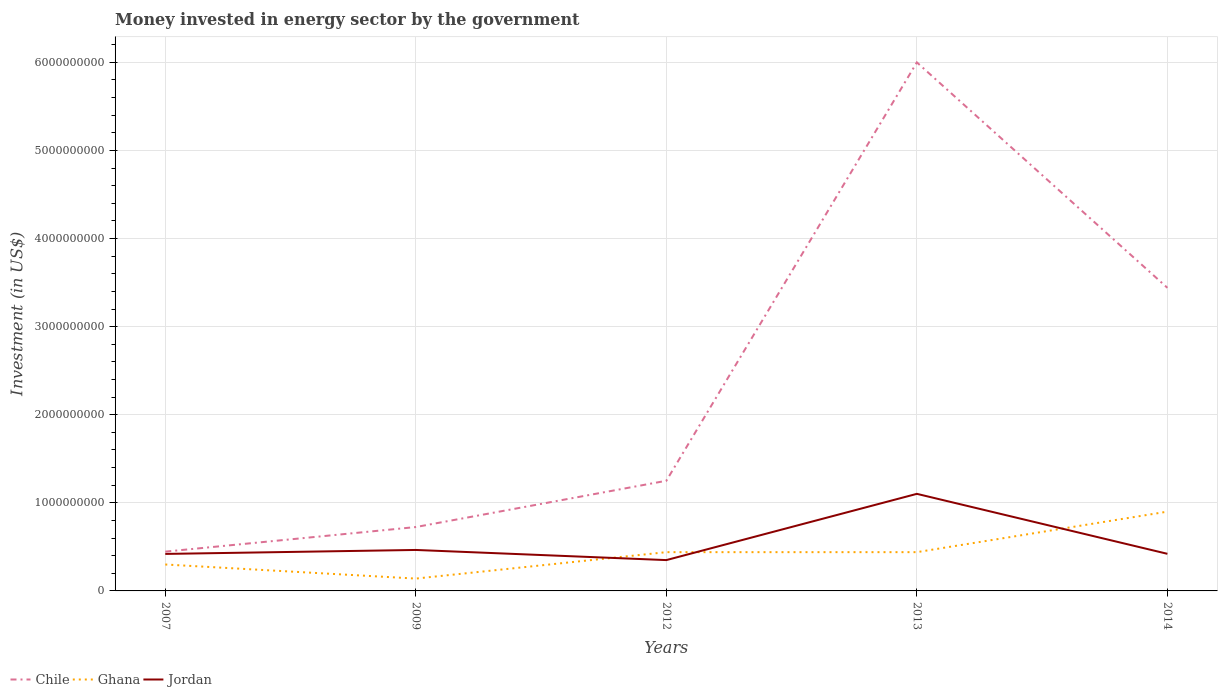Is the number of lines equal to the number of legend labels?
Ensure brevity in your answer.  Yes. Across all years, what is the maximum money spent in energy sector in Jordan?
Offer a very short reply. 3.50e+08. In which year was the money spent in energy sector in Jordan maximum?
Offer a terse response. 2012. What is the total money spent in energy sector in Ghana in the graph?
Provide a succinct answer. 1.60e+08. What is the difference between the highest and the second highest money spent in energy sector in Jordan?
Offer a terse response. 7.52e+08. How many years are there in the graph?
Provide a succinct answer. 5. What is the difference between two consecutive major ticks on the Y-axis?
Offer a terse response. 1.00e+09. Where does the legend appear in the graph?
Offer a terse response. Bottom left. How many legend labels are there?
Give a very brief answer. 3. How are the legend labels stacked?
Your response must be concise. Horizontal. What is the title of the graph?
Offer a very short reply. Money invested in energy sector by the government. What is the label or title of the Y-axis?
Give a very brief answer. Investment (in US$). What is the Investment (in US$) of Chile in 2007?
Make the answer very short. 4.46e+08. What is the Investment (in US$) of Ghana in 2007?
Offer a terse response. 3.00e+08. What is the Investment (in US$) of Jordan in 2007?
Your answer should be compact. 4.20e+08. What is the Investment (in US$) of Chile in 2009?
Keep it short and to the point. 7.25e+08. What is the Investment (in US$) in Ghana in 2009?
Give a very brief answer. 1.40e+08. What is the Investment (in US$) in Jordan in 2009?
Give a very brief answer. 4.65e+08. What is the Investment (in US$) in Chile in 2012?
Your response must be concise. 1.25e+09. What is the Investment (in US$) in Ghana in 2012?
Your answer should be very brief. 4.40e+08. What is the Investment (in US$) in Jordan in 2012?
Offer a very short reply. 3.50e+08. What is the Investment (in US$) of Chile in 2013?
Offer a terse response. 6.00e+09. What is the Investment (in US$) in Ghana in 2013?
Offer a very short reply. 4.40e+08. What is the Investment (in US$) of Jordan in 2013?
Keep it short and to the point. 1.10e+09. What is the Investment (in US$) in Chile in 2014?
Give a very brief answer. 3.44e+09. What is the Investment (in US$) in Ghana in 2014?
Offer a terse response. 9.00e+08. What is the Investment (in US$) in Jordan in 2014?
Keep it short and to the point. 4.21e+08. Across all years, what is the maximum Investment (in US$) in Chile?
Offer a terse response. 6.00e+09. Across all years, what is the maximum Investment (in US$) of Ghana?
Your answer should be compact. 9.00e+08. Across all years, what is the maximum Investment (in US$) of Jordan?
Give a very brief answer. 1.10e+09. Across all years, what is the minimum Investment (in US$) of Chile?
Your answer should be compact. 4.46e+08. Across all years, what is the minimum Investment (in US$) of Ghana?
Provide a succinct answer. 1.40e+08. Across all years, what is the minimum Investment (in US$) of Jordan?
Offer a very short reply. 3.50e+08. What is the total Investment (in US$) in Chile in the graph?
Provide a succinct answer. 1.19e+1. What is the total Investment (in US$) of Ghana in the graph?
Give a very brief answer. 2.22e+09. What is the total Investment (in US$) of Jordan in the graph?
Keep it short and to the point. 2.76e+09. What is the difference between the Investment (in US$) in Chile in 2007 and that in 2009?
Your response must be concise. -2.79e+08. What is the difference between the Investment (in US$) in Ghana in 2007 and that in 2009?
Provide a succinct answer. 1.60e+08. What is the difference between the Investment (in US$) in Jordan in 2007 and that in 2009?
Offer a very short reply. -4.50e+07. What is the difference between the Investment (in US$) in Chile in 2007 and that in 2012?
Your response must be concise. -8.05e+08. What is the difference between the Investment (in US$) of Ghana in 2007 and that in 2012?
Your response must be concise. -1.40e+08. What is the difference between the Investment (in US$) in Jordan in 2007 and that in 2012?
Your response must be concise. 7.00e+07. What is the difference between the Investment (in US$) of Chile in 2007 and that in 2013?
Offer a very short reply. -5.55e+09. What is the difference between the Investment (in US$) of Ghana in 2007 and that in 2013?
Provide a succinct answer. -1.40e+08. What is the difference between the Investment (in US$) in Jordan in 2007 and that in 2013?
Make the answer very short. -6.82e+08. What is the difference between the Investment (in US$) of Chile in 2007 and that in 2014?
Give a very brief answer. -2.99e+09. What is the difference between the Investment (in US$) of Ghana in 2007 and that in 2014?
Provide a short and direct response. -6.00e+08. What is the difference between the Investment (in US$) in Jordan in 2007 and that in 2014?
Give a very brief answer. -1.20e+06. What is the difference between the Investment (in US$) in Chile in 2009 and that in 2012?
Give a very brief answer. -5.25e+08. What is the difference between the Investment (in US$) in Ghana in 2009 and that in 2012?
Make the answer very short. -3.00e+08. What is the difference between the Investment (in US$) in Jordan in 2009 and that in 2012?
Give a very brief answer. 1.15e+08. What is the difference between the Investment (in US$) of Chile in 2009 and that in 2013?
Keep it short and to the point. -5.27e+09. What is the difference between the Investment (in US$) in Ghana in 2009 and that in 2013?
Offer a very short reply. -3.00e+08. What is the difference between the Investment (in US$) in Jordan in 2009 and that in 2013?
Your answer should be very brief. -6.37e+08. What is the difference between the Investment (in US$) in Chile in 2009 and that in 2014?
Your answer should be compact. -2.72e+09. What is the difference between the Investment (in US$) of Ghana in 2009 and that in 2014?
Ensure brevity in your answer.  -7.60e+08. What is the difference between the Investment (in US$) of Jordan in 2009 and that in 2014?
Give a very brief answer. 4.38e+07. What is the difference between the Investment (in US$) of Chile in 2012 and that in 2013?
Your response must be concise. -4.75e+09. What is the difference between the Investment (in US$) in Jordan in 2012 and that in 2013?
Your answer should be compact. -7.52e+08. What is the difference between the Investment (in US$) in Chile in 2012 and that in 2014?
Give a very brief answer. -2.19e+09. What is the difference between the Investment (in US$) of Ghana in 2012 and that in 2014?
Make the answer very short. -4.60e+08. What is the difference between the Investment (in US$) of Jordan in 2012 and that in 2014?
Ensure brevity in your answer.  -7.12e+07. What is the difference between the Investment (in US$) in Chile in 2013 and that in 2014?
Offer a very short reply. 2.56e+09. What is the difference between the Investment (in US$) of Ghana in 2013 and that in 2014?
Make the answer very short. -4.60e+08. What is the difference between the Investment (in US$) in Jordan in 2013 and that in 2014?
Provide a succinct answer. 6.81e+08. What is the difference between the Investment (in US$) in Chile in 2007 and the Investment (in US$) in Ghana in 2009?
Provide a short and direct response. 3.06e+08. What is the difference between the Investment (in US$) of Chile in 2007 and the Investment (in US$) of Jordan in 2009?
Ensure brevity in your answer.  -1.90e+07. What is the difference between the Investment (in US$) of Ghana in 2007 and the Investment (in US$) of Jordan in 2009?
Ensure brevity in your answer.  -1.65e+08. What is the difference between the Investment (in US$) in Chile in 2007 and the Investment (in US$) in Ghana in 2012?
Offer a terse response. 5.96e+06. What is the difference between the Investment (in US$) in Chile in 2007 and the Investment (in US$) in Jordan in 2012?
Your response must be concise. 9.60e+07. What is the difference between the Investment (in US$) in Ghana in 2007 and the Investment (in US$) in Jordan in 2012?
Your response must be concise. -5.00e+07. What is the difference between the Investment (in US$) in Chile in 2007 and the Investment (in US$) in Ghana in 2013?
Make the answer very short. 5.96e+06. What is the difference between the Investment (in US$) in Chile in 2007 and the Investment (in US$) in Jordan in 2013?
Ensure brevity in your answer.  -6.56e+08. What is the difference between the Investment (in US$) in Ghana in 2007 and the Investment (in US$) in Jordan in 2013?
Keep it short and to the point. -8.02e+08. What is the difference between the Investment (in US$) of Chile in 2007 and the Investment (in US$) of Ghana in 2014?
Ensure brevity in your answer.  -4.54e+08. What is the difference between the Investment (in US$) of Chile in 2007 and the Investment (in US$) of Jordan in 2014?
Provide a short and direct response. 2.48e+07. What is the difference between the Investment (in US$) in Ghana in 2007 and the Investment (in US$) in Jordan in 2014?
Give a very brief answer. -1.21e+08. What is the difference between the Investment (in US$) of Chile in 2009 and the Investment (in US$) of Ghana in 2012?
Your answer should be very brief. 2.85e+08. What is the difference between the Investment (in US$) in Chile in 2009 and the Investment (in US$) in Jordan in 2012?
Keep it short and to the point. 3.75e+08. What is the difference between the Investment (in US$) of Ghana in 2009 and the Investment (in US$) of Jordan in 2012?
Keep it short and to the point. -2.10e+08. What is the difference between the Investment (in US$) of Chile in 2009 and the Investment (in US$) of Ghana in 2013?
Make the answer very short. 2.85e+08. What is the difference between the Investment (in US$) in Chile in 2009 and the Investment (in US$) in Jordan in 2013?
Your answer should be very brief. -3.77e+08. What is the difference between the Investment (in US$) in Ghana in 2009 and the Investment (in US$) in Jordan in 2013?
Give a very brief answer. -9.62e+08. What is the difference between the Investment (in US$) in Chile in 2009 and the Investment (in US$) in Ghana in 2014?
Offer a very short reply. -1.75e+08. What is the difference between the Investment (in US$) of Chile in 2009 and the Investment (in US$) of Jordan in 2014?
Your response must be concise. 3.04e+08. What is the difference between the Investment (in US$) in Ghana in 2009 and the Investment (in US$) in Jordan in 2014?
Offer a very short reply. -2.81e+08. What is the difference between the Investment (in US$) in Chile in 2012 and the Investment (in US$) in Ghana in 2013?
Offer a terse response. 8.10e+08. What is the difference between the Investment (in US$) of Chile in 2012 and the Investment (in US$) of Jordan in 2013?
Make the answer very short. 1.48e+08. What is the difference between the Investment (in US$) of Ghana in 2012 and the Investment (in US$) of Jordan in 2013?
Offer a very short reply. -6.62e+08. What is the difference between the Investment (in US$) of Chile in 2012 and the Investment (in US$) of Ghana in 2014?
Provide a short and direct response. 3.50e+08. What is the difference between the Investment (in US$) of Chile in 2012 and the Investment (in US$) of Jordan in 2014?
Your answer should be compact. 8.29e+08. What is the difference between the Investment (in US$) of Ghana in 2012 and the Investment (in US$) of Jordan in 2014?
Ensure brevity in your answer.  1.88e+07. What is the difference between the Investment (in US$) of Chile in 2013 and the Investment (in US$) of Ghana in 2014?
Ensure brevity in your answer.  5.10e+09. What is the difference between the Investment (in US$) in Chile in 2013 and the Investment (in US$) in Jordan in 2014?
Your response must be concise. 5.58e+09. What is the difference between the Investment (in US$) in Ghana in 2013 and the Investment (in US$) in Jordan in 2014?
Make the answer very short. 1.88e+07. What is the average Investment (in US$) in Chile per year?
Your answer should be compact. 2.37e+09. What is the average Investment (in US$) of Ghana per year?
Offer a terse response. 4.44e+08. What is the average Investment (in US$) of Jordan per year?
Your answer should be very brief. 5.52e+08. In the year 2007, what is the difference between the Investment (in US$) in Chile and Investment (in US$) in Ghana?
Offer a very short reply. 1.46e+08. In the year 2007, what is the difference between the Investment (in US$) of Chile and Investment (in US$) of Jordan?
Offer a terse response. 2.60e+07. In the year 2007, what is the difference between the Investment (in US$) in Ghana and Investment (in US$) in Jordan?
Offer a terse response. -1.20e+08. In the year 2009, what is the difference between the Investment (in US$) in Chile and Investment (in US$) in Ghana?
Your answer should be compact. 5.85e+08. In the year 2009, what is the difference between the Investment (in US$) in Chile and Investment (in US$) in Jordan?
Your response must be concise. 2.60e+08. In the year 2009, what is the difference between the Investment (in US$) in Ghana and Investment (in US$) in Jordan?
Provide a succinct answer. -3.25e+08. In the year 2012, what is the difference between the Investment (in US$) of Chile and Investment (in US$) of Ghana?
Provide a short and direct response. 8.10e+08. In the year 2012, what is the difference between the Investment (in US$) of Chile and Investment (in US$) of Jordan?
Keep it short and to the point. 9.00e+08. In the year 2012, what is the difference between the Investment (in US$) of Ghana and Investment (in US$) of Jordan?
Keep it short and to the point. 9.00e+07. In the year 2013, what is the difference between the Investment (in US$) of Chile and Investment (in US$) of Ghana?
Your response must be concise. 5.56e+09. In the year 2013, what is the difference between the Investment (in US$) in Chile and Investment (in US$) in Jordan?
Provide a short and direct response. 4.90e+09. In the year 2013, what is the difference between the Investment (in US$) in Ghana and Investment (in US$) in Jordan?
Keep it short and to the point. -6.62e+08. In the year 2014, what is the difference between the Investment (in US$) in Chile and Investment (in US$) in Ghana?
Make the answer very short. 2.54e+09. In the year 2014, what is the difference between the Investment (in US$) of Chile and Investment (in US$) of Jordan?
Your answer should be compact. 3.02e+09. In the year 2014, what is the difference between the Investment (in US$) of Ghana and Investment (in US$) of Jordan?
Your answer should be very brief. 4.79e+08. What is the ratio of the Investment (in US$) of Chile in 2007 to that in 2009?
Make the answer very short. 0.61. What is the ratio of the Investment (in US$) of Ghana in 2007 to that in 2009?
Ensure brevity in your answer.  2.14. What is the ratio of the Investment (in US$) of Jordan in 2007 to that in 2009?
Offer a very short reply. 0.9. What is the ratio of the Investment (in US$) of Chile in 2007 to that in 2012?
Keep it short and to the point. 0.36. What is the ratio of the Investment (in US$) of Ghana in 2007 to that in 2012?
Make the answer very short. 0.68. What is the ratio of the Investment (in US$) in Jordan in 2007 to that in 2012?
Offer a very short reply. 1.2. What is the ratio of the Investment (in US$) in Chile in 2007 to that in 2013?
Provide a succinct answer. 0.07. What is the ratio of the Investment (in US$) of Ghana in 2007 to that in 2013?
Ensure brevity in your answer.  0.68. What is the ratio of the Investment (in US$) of Jordan in 2007 to that in 2013?
Give a very brief answer. 0.38. What is the ratio of the Investment (in US$) of Chile in 2007 to that in 2014?
Your response must be concise. 0.13. What is the ratio of the Investment (in US$) in Ghana in 2007 to that in 2014?
Provide a short and direct response. 0.33. What is the ratio of the Investment (in US$) in Jordan in 2007 to that in 2014?
Keep it short and to the point. 1. What is the ratio of the Investment (in US$) of Chile in 2009 to that in 2012?
Offer a terse response. 0.58. What is the ratio of the Investment (in US$) of Ghana in 2009 to that in 2012?
Keep it short and to the point. 0.32. What is the ratio of the Investment (in US$) in Jordan in 2009 to that in 2012?
Offer a terse response. 1.33. What is the ratio of the Investment (in US$) in Chile in 2009 to that in 2013?
Offer a very short reply. 0.12. What is the ratio of the Investment (in US$) in Ghana in 2009 to that in 2013?
Offer a terse response. 0.32. What is the ratio of the Investment (in US$) in Jordan in 2009 to that in 2013?
Your response must be concise. 0.42. What is the ratio of the Investment (in US$) in Chile in 2009 to that in 2014?
Your answer should be very brief. 0.21. What is the ratio of the Investment (in US$) in Ghana in 2009 to that in 2014?
Your response must be concise. 0.16. What is the ratio of the Investment (in US$) in Jordan in 2009 to that in 2014?
Offer a very short reply. 1.1. What is the ratio of the Investment (in US$) of Chile in 2012 to that in 2013?
Offer a terse response. 0.21. What is the ratio of the Investment (in US$) of Jordan in 2012 to that in 2013?
Make the answer very short. 0.32. What is the ratio of the Investment (in US$) in Chile in 2012 to that in 2014?
Make the answer very short. 0.36. What is the ratio of the Investment (in US$) of Ghana in 2012 to that in 2014?
Ensure brevity in your answer.  0.49. What is the ratio of the Investment (in US$) in Jordan in 2012 to that in 2014?
Your answer should be compact. 0.83. What is the ratio of the Investment (in US$) in Chile in 2013 to that in 2014?
Give a very brief answer. 1.74. What is the ratio of the Investment (in US$) of Ghana in 2013 to that in 2014?
Give a very brief answer. 0.49. What is the ratio of the Investment (in US$) in Jordan in 2013 to that in 2014?
Make the answer very short. 2.62. What is the difference between the highest and the second highest Investment (in US$) of Chile?
Your response must be concise. 2.56e+09. What is the difference between the highest and the second highest Investment (in US$) of Ghana?
Offer a very short reply. 4.60e+08. What is the difference between the highest and the second highest Investment (in US$) in Jordan?
Your response must be concise. 6.37e+08. What is the difference between the highest and the lowest Investment (in US$) of Chile?
Your answer should be compact. 5.55e+09. What is the difference between the highest and the lowest Investment (in US$) in Ghana?
Offer a terse response. 7.60e+08. What is the difference between the highest and the lowest Investment (in US$) of Jordan?
Keep it short and to the point. 7.52e+08. 